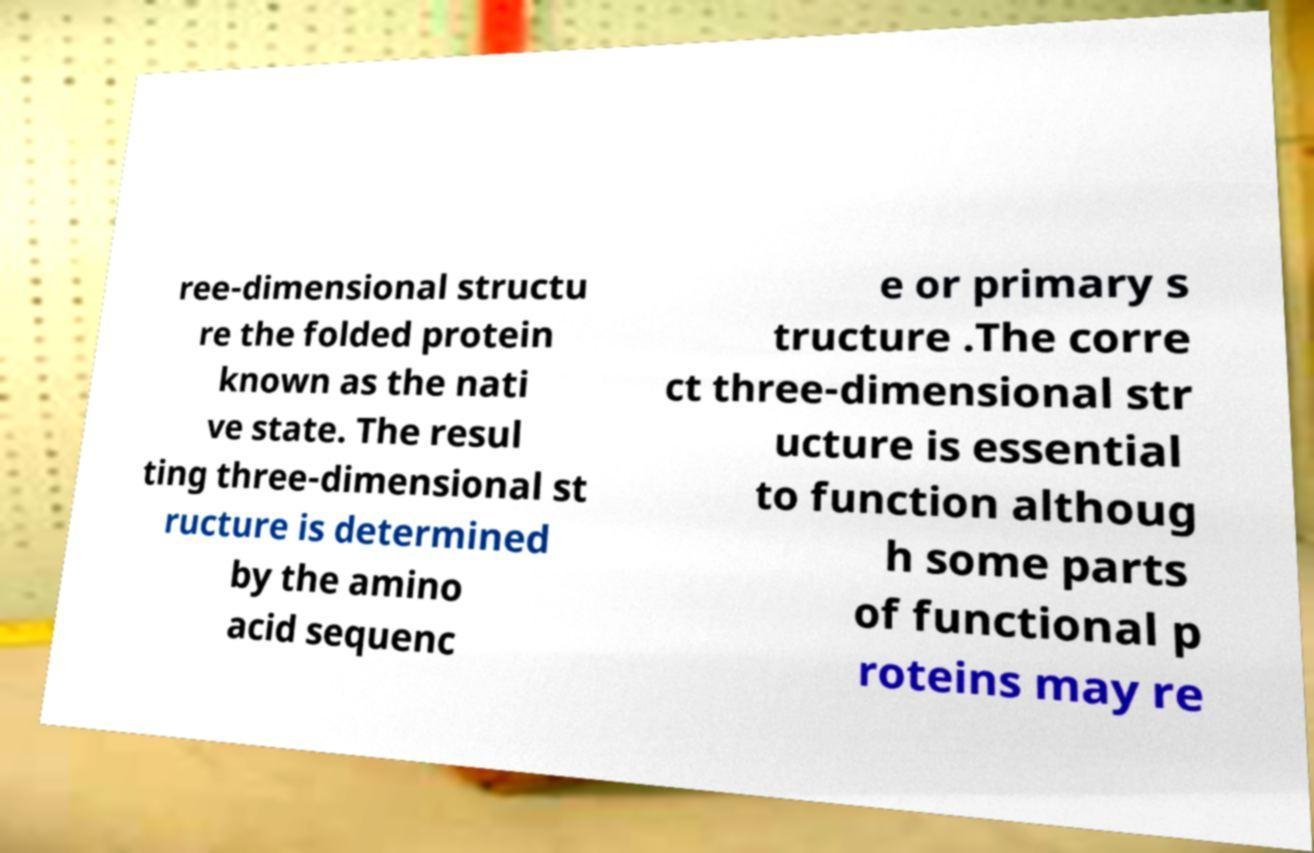What messages or text are displayed in this image? I need them in a readable, typed format. ree-dimensional structu re the folded protein known as the nati ve state. The resul ting three-dimensional st ructure is determined by the amino acid sequenc e or primary s tructure .The corre ct three-dimensional str ucture is essential to function althoug h some parts of functional p roteins may re 